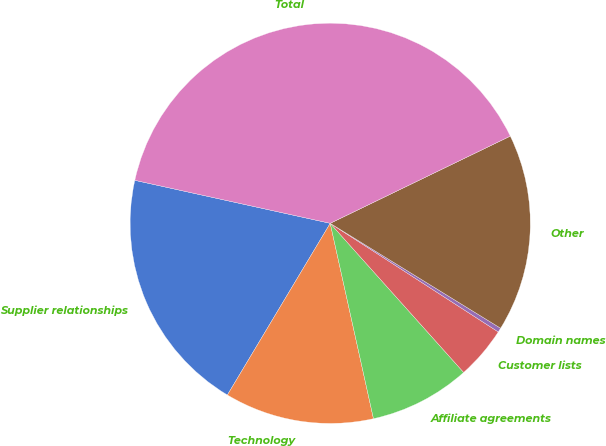Convert chart to OTSL. <chart><loc_0><loc_0><loc_500><loc_500><pie_chart><fcel>Supplier relationships<fcel>Technology<fcel>Affiliate agreements<fcel>Customer lists<fcel>Domain names<fcel>Other<fcel>Total<nl><fcel>19.86%<fcel>12.06%<fcel>8.15%<fcel>4.25%<fcel>0.35%<fcel>15.96%<fcel>39.38%<nl></chart> 